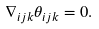Convert formula to latex. <formula><loc_0><loc_0><loc_500><loc_500>\nabla _ { i j k } \theta _ { i j k } = 0 .</formula> 